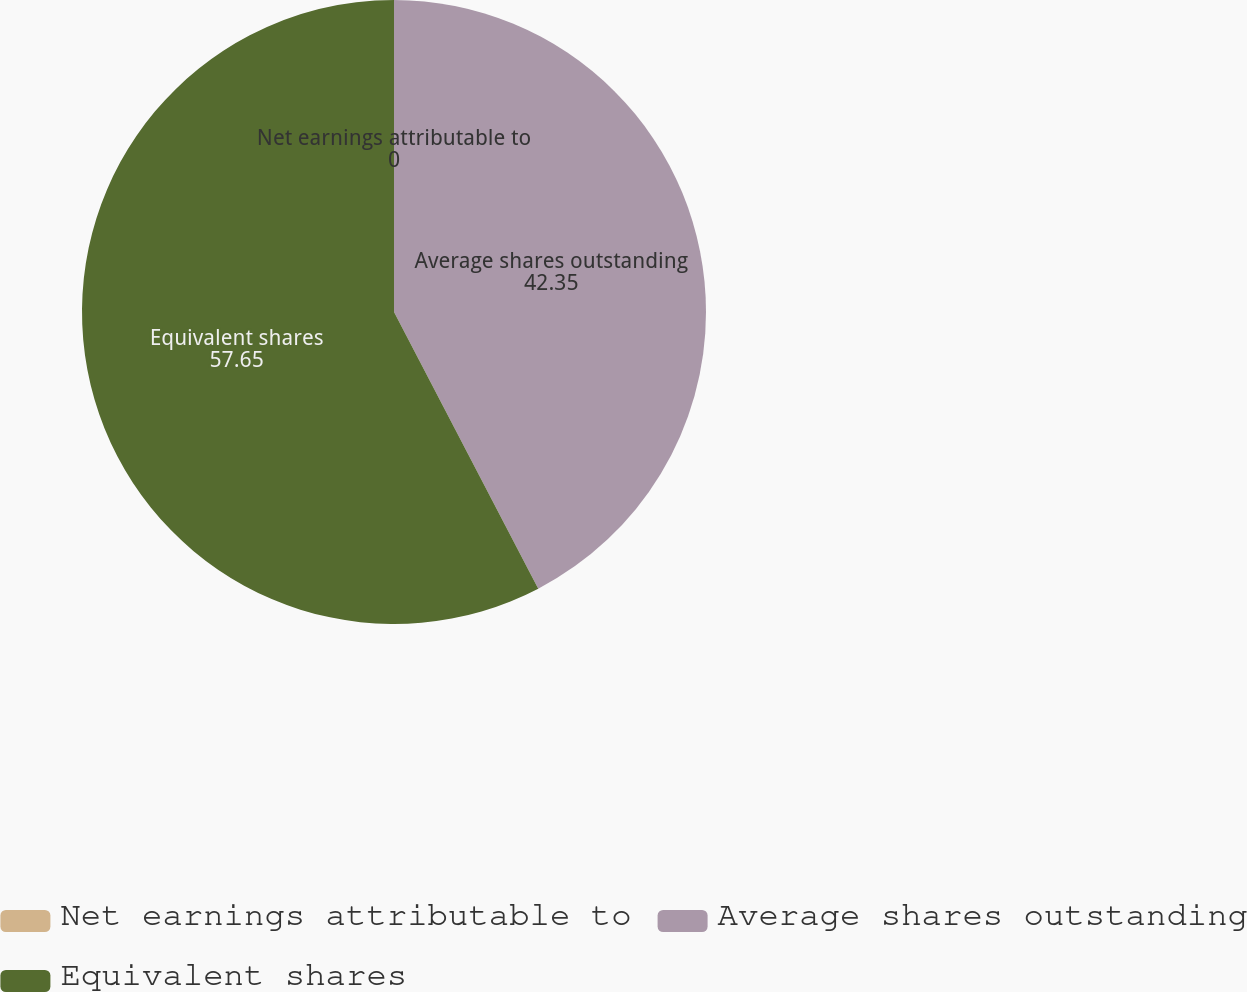Convert chart. <chart><loc_0><loc_0><loc_500><loc_500><pie_chart><fcel>Net earnings attributable to<fcel>Average shares outstanding<fcel>Equivalent shares<nl><fcel>0.0%<fcel>42.35%<fcel>57.65%<nl></chart> 